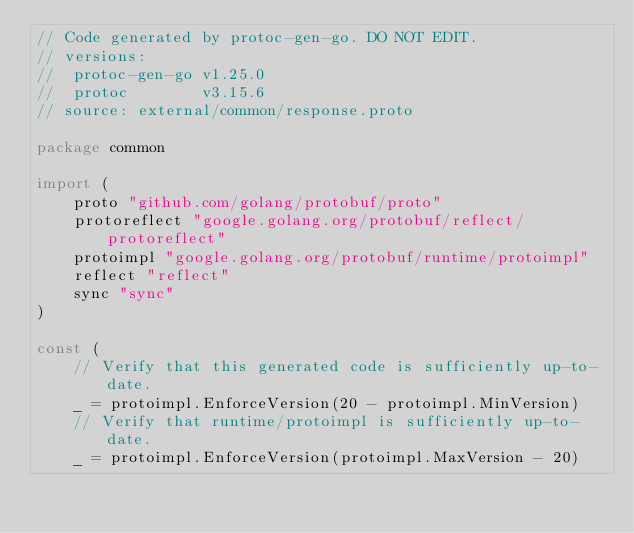<code> <loc_0><loc_0><loc_500><loc_500><_Go_>// Code generated by protoc-gen-go. DO NOT EDIT.
// versions:
// 	protoc-gen-go v1.25.0
// 	protoc        v3.15.6
// source: external/common/response.proto

package common

import (
	proto "github.com/golang/protobuf/proto"
	protoreflect "google.golang.org/protobuf/reflect/protoreflect"
	protoimpl "google.golang.org/protobuf/runtime/protoimpl"
	reflect "reflect"
	sync "sync"
)

const (
	// Verify that this generated code is sufficiently up-to-date.
	_ = protoimpl.EnforceVersion(20 - protoimpl.MinVersion)
	// Verify that runtime/protoimpl is sufficiently up-to-date.
	_ = protoimpl.EnforceVersion(protoimpl.MaxVersion - 20)</code> 